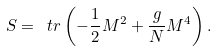<formula> <loc_0><loc_0><loc_500><loc_500>S = \ t r \left ( - \frac { 1 } { 2 } M ^ { 2 } + \frac { g } { N } M ^ { 4 } \right ) .</formula> 